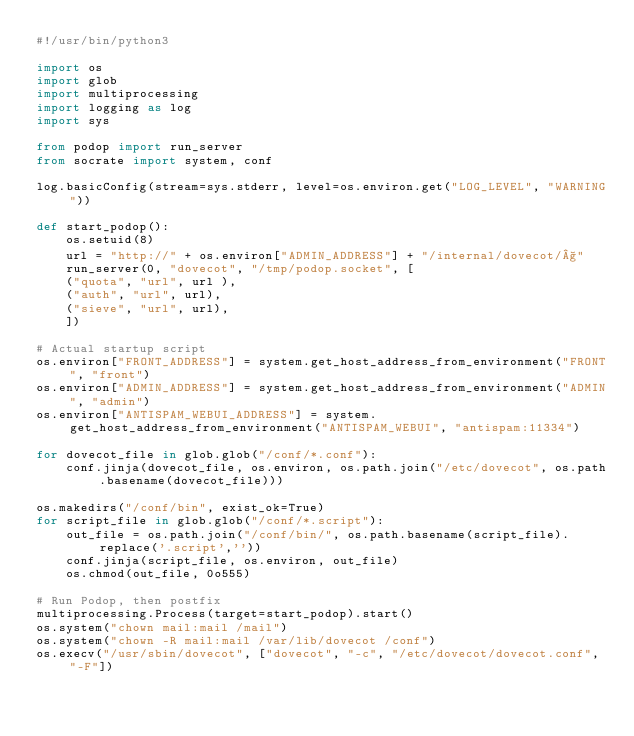Convert code to text. <code><loc_0><loc_0><loc_500><loc_500><_Python_>#!/usr/bin/python3

import os
import glob
import multiprocessing
import logging as log
import sys

from podop import run_server
from socrate import system, conf

log.basicConfig(stream=sys.stderr, level=os.environ.get("LOG_LEVEL", "WARNING"))

def start_podop():
    os.setuid(8)
    url = "http://" + os.environ["ADMIN_ADDRESS"] + "/internal/dovecot/§"
    run_server(0, "dovecot", "/tmp/podop.socket", [
		("quota", "url", url ),
		("auth", "url", url),
		("sieve", "url", url),
    ])

# Actual startup script
os.environ["FRONT_ADDRESS"] = system.get_host_address_from_environment("FRONT", "front")
os.environ["ADMIN_ADDRESS"] = system.get_host_address_from_environment("ADMIN", "admin")
os.environ["ANTISPAM_WEBUI_ADDRESS"] = system.get_host_address_from_environment("ANTISPAM_WEBUI", "antispam:11334")

for dovecot_file in glob.glob("/conf/*.conf"):
    conf.jinja(dovecot_file, os.environ, os.path.join("/etc/dovecot", os.path.basename(dovecot_file)))

os.makedirs("/conf/bin", exist_ok=True)
for script_file in glob.glob("/conf/*.script"):
    out_file = os.path.join("/conf/bin/", os.path.basename(script_file).replace('.script',''))
    conf.jinja(script_file, os.environ, out_file)
    os.chmod(out_file, 0o555)

# Run Podop, then postfix
multiprocessing.Process(target=start_podop).start()
os.system("chown mail:mail /mail")
os.system("chown -R mail:mail /var/lib/dovecot /conf")
os.execv("/usr/sbin/dovecot", ["dovecot", "-c", "/etc/dovecot/dovecot.conf", "-F"])
</code> 